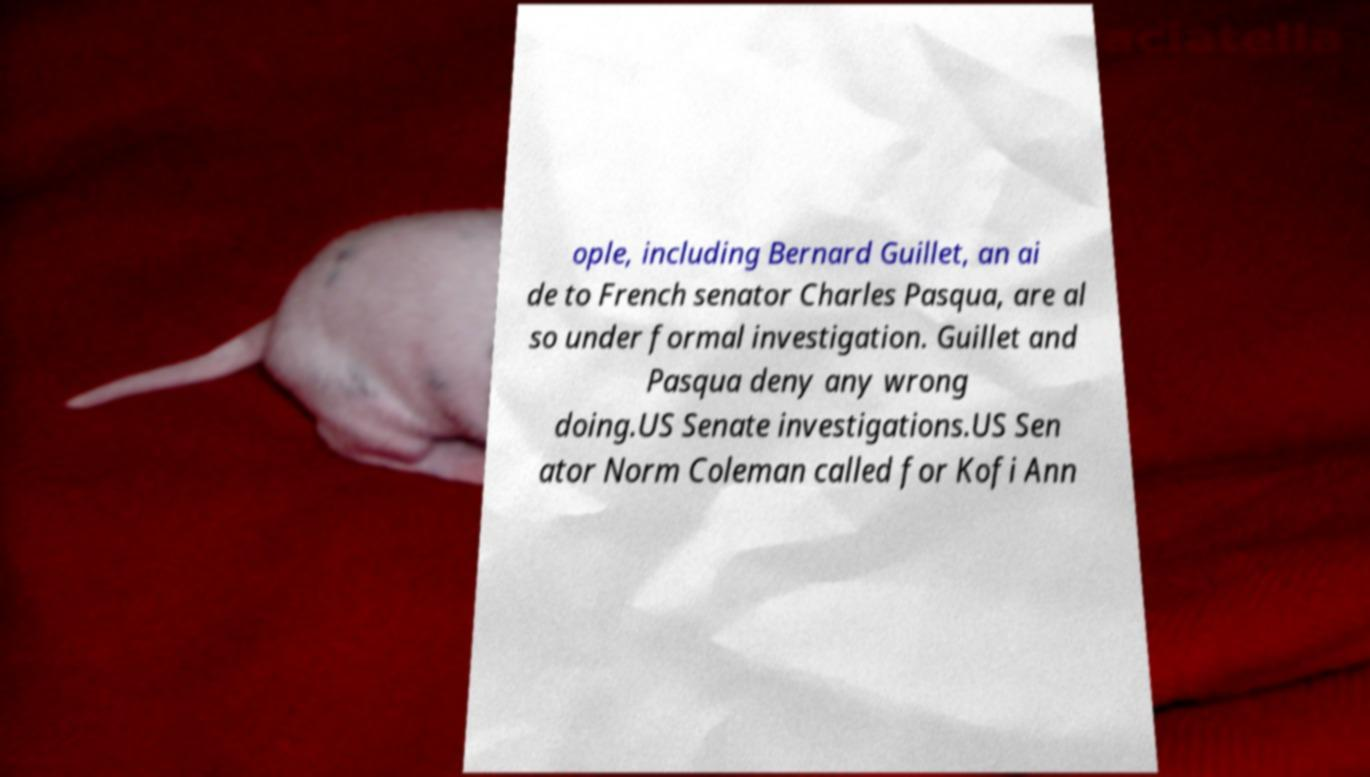I need the written content from this picture converted into text. Can you do that? ople, including Bernard Guillet, an ai de to French senator Charles Pasqua, are al so under formal investigation. Guillet and Pasqua deny any wrong doing.US Senate investigations.US Sen ator Norm Coleman called for Kofi Ann 